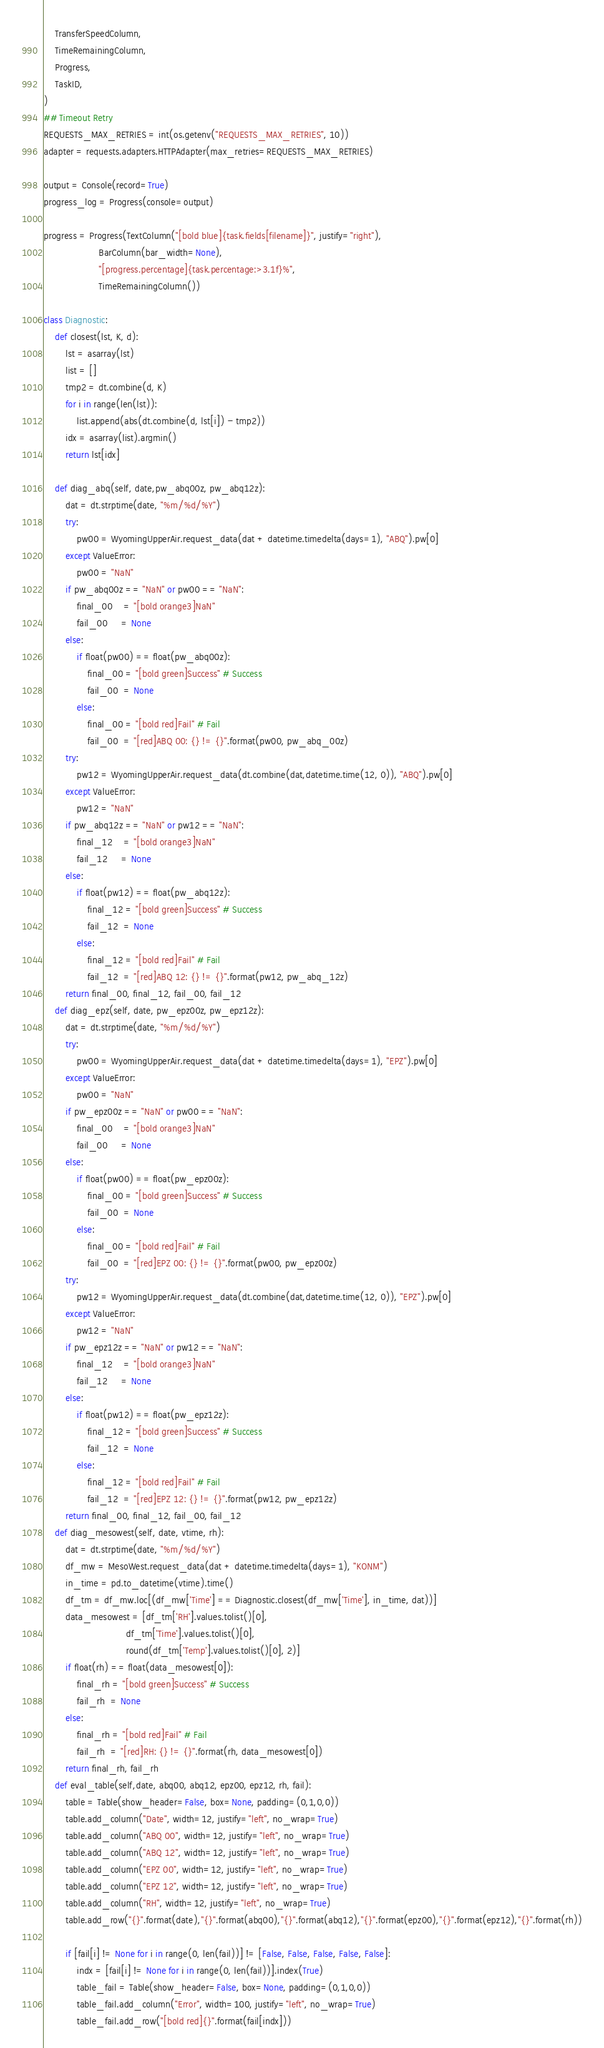<code> <loc_0><loc_0><loc_500><loc_500><_Python_>    TransferSpeedColumn,
    TimeRemainingColumn,
    Progress,
    TaskID,
)
## Timeout Retry
REQUESTS_MAX_RETRIES = int(os.getenv("REQUESTS_MAX_RETRIES", 10))
adapter = requests.adapters.HTTPAdapter(max_retries=REQUESTS_MAX_RETRIES)

output = Console(record=True)
progress_log = Progress(console=output)

progress = Progress(TextColumn("[bold blue]{task.fields[filename]}", justify="right"),
                    BarColumn(bar_width=None),
                    "[progress.percentage]{task.percentage:>3.1f}%",
                    TimeRemainingColumn())

class Diagnostic:
    def closest(lst, K, d):
        lst = asarray(lst)
        list = []
        tmp2 = dt.combine(d, K)
        for i in range(len(lst)):
            list.append(abs(dt.combine(d, lst[i]) - tmp2))
        idx = asarray(list).argmin()
        return lst[idx]

    def diag_abq(self, date,pw_abq00z, pw_abq12z):
        dat = dt.strptime(date, "%m/%d/%Y")
        try:
            pw00 = WyomingUpperAir.request_data(dat + datetime.timedelta(days=1), "ABQ").pw[0]
        except ValueError:
            pw00 = "NaN"
        if pw_abq00z == "NaN" or pw00 == "NaN":
            final_00    = "[bold orange3]NaN"
            fail_00     = None
        else:
            if float(pw00) == float(pw_abq00z):
                final_00 = "[bold green]Success" # Success
                fail_00  = None
            else:
                final_00 = "[bold red]Fail" # Fail
                fail_00  = "[red]ABQ 00: {} != {}".format(pw00, pw_abq_00z)
        try:
            pw12 = WyomingUpperAir.request_data(dt.combine(dat,datetime.time(12, 0)), "ABQ").pw[0]
        except ValueError:
            pw12 = "NaN"
        if pw_abq12z == "NaN" or pw12 == "NaN":
            final_12    = "[bold orange3]NaN"
            fail_12     = None
        else:
            if float(pw12) == float(pw_abq12z):
                final_12 = "[bold green]Success" # Success
                fail_12  = None
            else:
                final_12 = "[bold red]Fail" # Fail
                fail_12  = "[red]ABQ 12: {} != {}".format(pw12, pw_abq_12z)
        return final_00, final_12, fail_00, fail_12
    def diag_epz(self, date, pw_epz00z, pw_epz12z):
        dat = dt.strptime(date, "%m/%d/%Y")
        try:
            pw00 = WyomingUpperAir.request_data(dat + datetime.timedelta(days=1), "EPZ").pw[0]
        except ValueError:
            pw00 = "NaN"
        if pw_epz00z == "NaN" or pw00 == "NaN":
            final_00    = "[bold orange3]NaN"
            fail_00     = None
        else:
            if float(pw00) == float(pw_epz00z):
                final_00 = "[bold green]Success" # Success
                fail_00  = None
            else:
                final_00 = "[bold red]Fail" # Fail
                fail_00  = "[red]EPZ 00: {} != {}".format(pw00, pw_epz00z)
        try:
            pw12 = WyomingUpperAir.request_data(dt.combine(dat,datetime.time(12, 0)), "EPZ").pw[0]
        except ValueError:
            pw12 = "NaN"
        if pw_epz12z == "NaN" or pw12 == "NaN":
            final_12    = "[bold orange3]NaN"
            fail_12     = None
        else:
            if float(pw12) == float(pw_epz12z):
                final_12 = "[bold green]Success" # Success
                fail_12  = None
            else:
                final_12 = "[bold red]Fail" # Fail
                fail_12  = "[red]EPZ 12: {} != {}".format(pw12, pw_epz12z)
        return final_00, final_12, fail_00, fail_12
    def diag_mesowest(self, date, vtime, rh):
        dat = dt.strptime(date, "%m/%d/%Y")
        df_mw = MesoWest.request_data(dat + datetime.timedelta(days=1), "KONM")
        in_time = pd.to_datetime(vtime).time()
        df_tm = df_mw.loc[(df_mw['Time'] == Diagnostic.closest(df_mw['Time'], in_time, dat))]
        data_mesowest = [df_tm['RH'].values.tolist()[0],
                              df_tm['Time'].values.tolist()[0],
                              round(df_tm['Temp'].values.tolist()[0], 2)]
        if float(rh) == float(data_mesowest[0]):
            final_rh = "[bold green]Success" # Success
            fail_rh  = None
        else:
            final_rh = "[bold red]Fail" # Fail
            fail_rh  = "[red]RH: {} != {}".format(rh, data_mesowest[0])
        return final_rh, fail_rh
    def eval_table(self,date, abq00, abq12, epz00, epz12, rh, fail):
        table = Table(show_header=False, box=None, padding=(0,1,0,0))
        table.add_column("Date", width=12, justify="left", no_wrap=True)
        table.add_column("ABQ 00", width=12, justify="left", no_wrap=True)
        table.add_column("ABQ 12", width=12, justify="left", no_wrap=True)
        table.add_column("EPZ 00", width=12, justify="left", no_wrap=True)
        table.add_column("EPZ 12", width=12, justify="left", no_wrap=True)
        table.add_column("RH", width=12, justify="left", no_wrap=True)
        table.add_row("{}".format(date),"{}".format(abq00),"{}".format(abq12),"{}".format(epz00),"{}".format(epz12),"{}".format(rh))

        if [fail[i] != None for i in range(0, len(fail))] != [False, False, False, False, False]:
            indx = [fail[i] != None for i in range(0, len(fail))].index(True)
            table_fail = Table(show_header=False, box=None, padding=(0,1,0,0))
            table_fail.add_column("Error", width=100, justify="left", no_wrap=True)
            table_fail.add_row("[bold red]{}".format(fail[indx]))</code> 